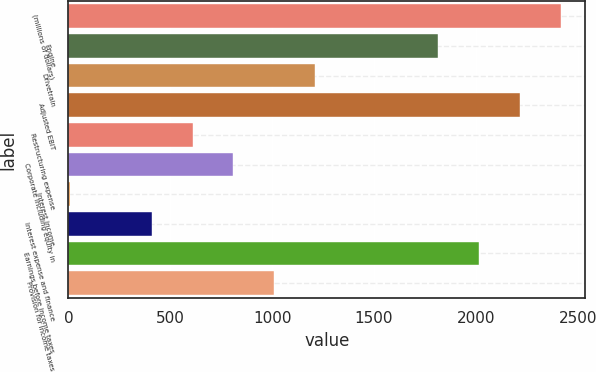Convert chart to OTSL. <chart><loc_0><loc_0><loc_500><loc_500><bar_chart><fcel>(millions of dollars)<fcel>Engine<fcel>Drivetrain<fcel>Adjusted EBIT<fcel>Restructuring expense<fcel>Corporate including equity in<fcel>Interest income<fcel>Interest expense and finance<fcel>Earnings before income taxes<fcel>Provision for income taxes<nl><fcel>2416.5<fcel>1814.25<fcel>1212<fcel>2215.75<fcel>609.75<fcel>810.5<fcel>7.5<fcel>409<fcel>2015<fcel>1011.25<nl></chart> 